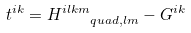Convert formula to latex. <formula><loc_0><loc_0><loc_500><loc_500>t ^ { i k } = H ^ { i l k m } _ { \quad q u a d , l m } - G ^ { i k }</formula> 